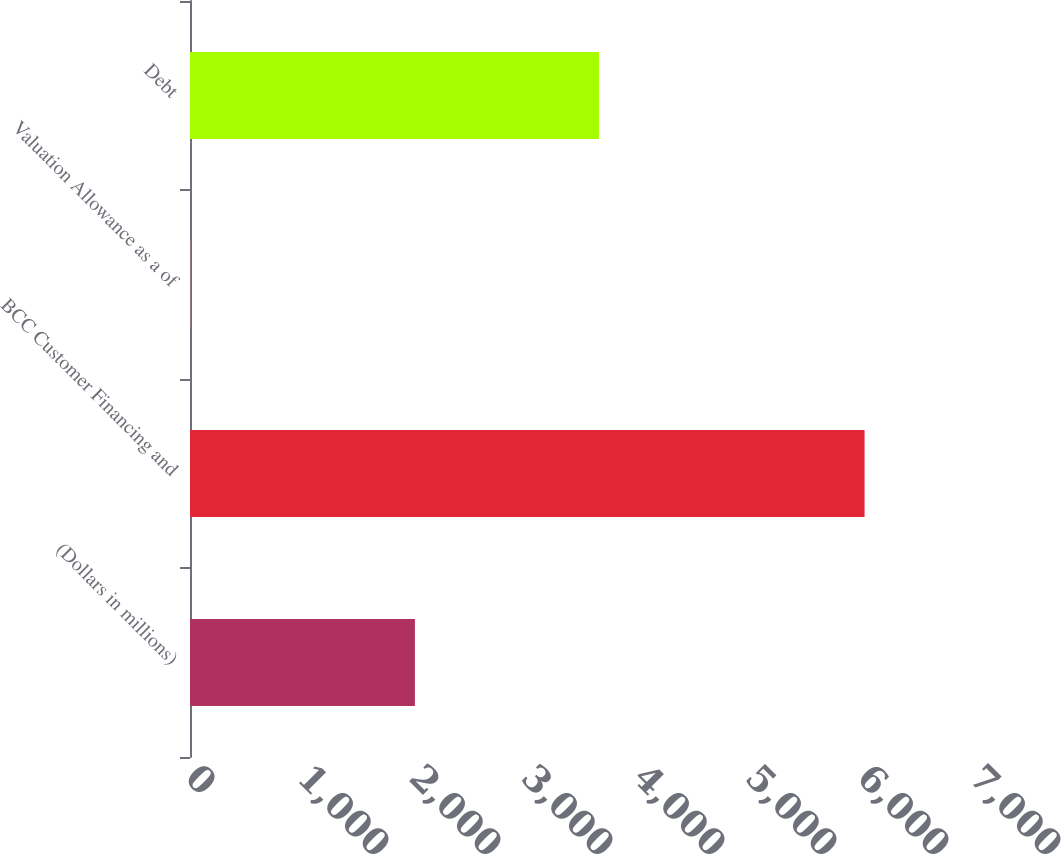<chart> <loc_0><loc_0><loc_500><loc_500><bar_chart><fcel>(Dollars in millions)<fcel>BCC Customer Financing and<fcel>Valuation Allowance as a of<fcel>Debt<nl><fcel>2008<fcel>6023<fcel>2.1<fcel>3652<nl></chart> 